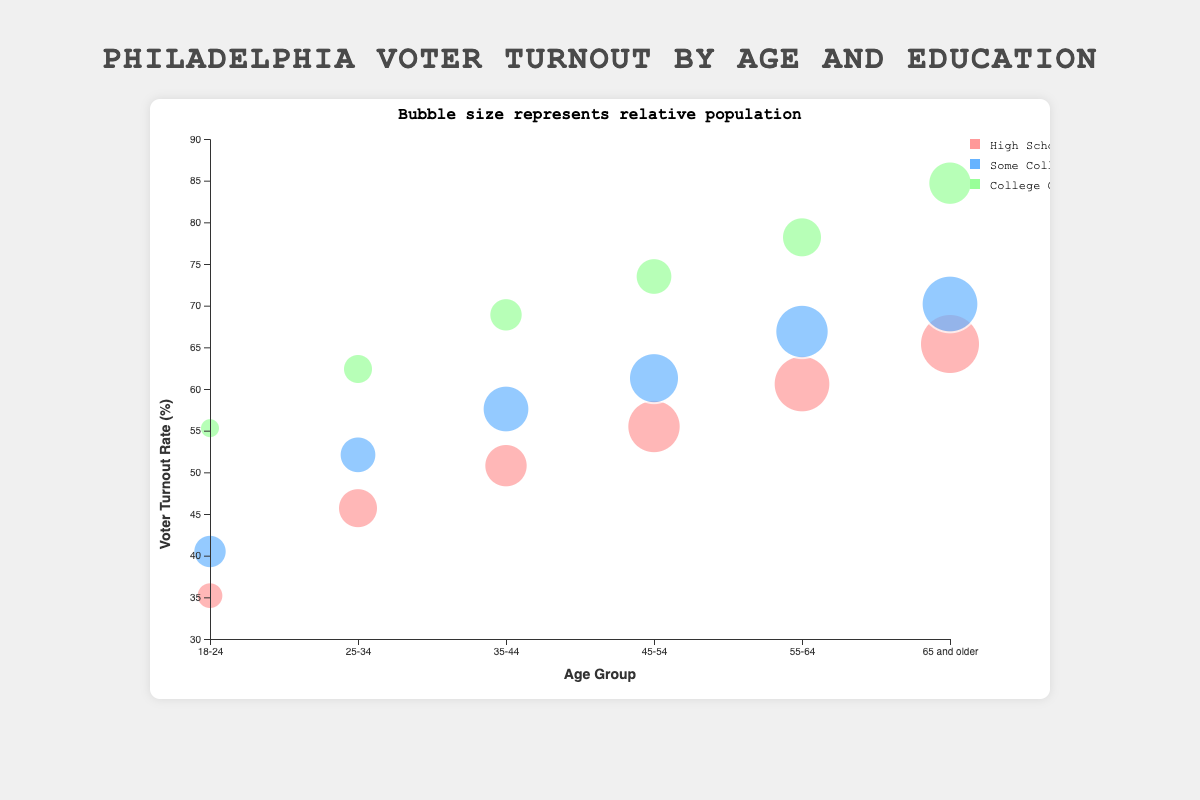What is the voter turnout rate for people aged 18-24 with some college education? Locate the bubble for the age group 18-24 and education level Some College, then read the voter turnout rate from the chart.
Answer: 40.5% How does the voter turnout rate for College Graduates aged 65 and older compare with those aged 18-24? Compare the voter turnout rates for College Graduates in the age groups 65 and older and 18-24. The rates are 84.7% and 55.3%, respectively, which shows 65 and older is higher.
Answer: 65 and older has a higher turnout Which age group has the largest bubble size for High School or less education level? Look at the bubbles for High School or less education level and find the largest one. The age group 65 and older has the largest bubble size of 3000.
Answer: 65 and older What's the average voter turnout rate for people aged 25-34? Calculate the average of the voter turnout rates for the age group 25-34 across all education levels: (45.7 + 52.1 + 62.4) / 3 = 53.4%
Answer: 53.4% Is there a trend in voter turnout rate with increasing age among those with College Graduate education? Observe the bubbles of College Graduates across increasing age groups and note the voter turnout rates. The trend shows an increase from 18-24 (55.3%) to 65 and older (84.7%).
Answer: Increasing trend For which education level does the 45-54 age group have the highest turnout rate? Compare the voter turnout rates within the 45-54 age group across all education levels: High School or less (55.5%), Some College (61.3%), College Graduate (73.5%). The highest is College Graduate.
Answer: College Graduate What's the bubble size for the 35-44 age group with some college education? Identify the bubble for the 35-44 age group with some college education and read the bubble size.
Answer: 2600 How much higher is the voter turnout rate for 55-64 age group with College Graduate education compared to High School or less? Subtract the voter turnout rate for High School or less from that for College Graduate within the 55-64 age group: 78.2% - 60.6% = 17.6%
Answer: 17.6% Which age group has the lowest voter turnout rate for College Graduates? Look at the voter turnout rates for College Graduates across all age groups and find the lowest: 18-24 has 55.3%
Answer: 18-24 